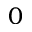Convert formula to latex. <formula><loc_0><loc_0><loc_500><loc_500>0</formula> 